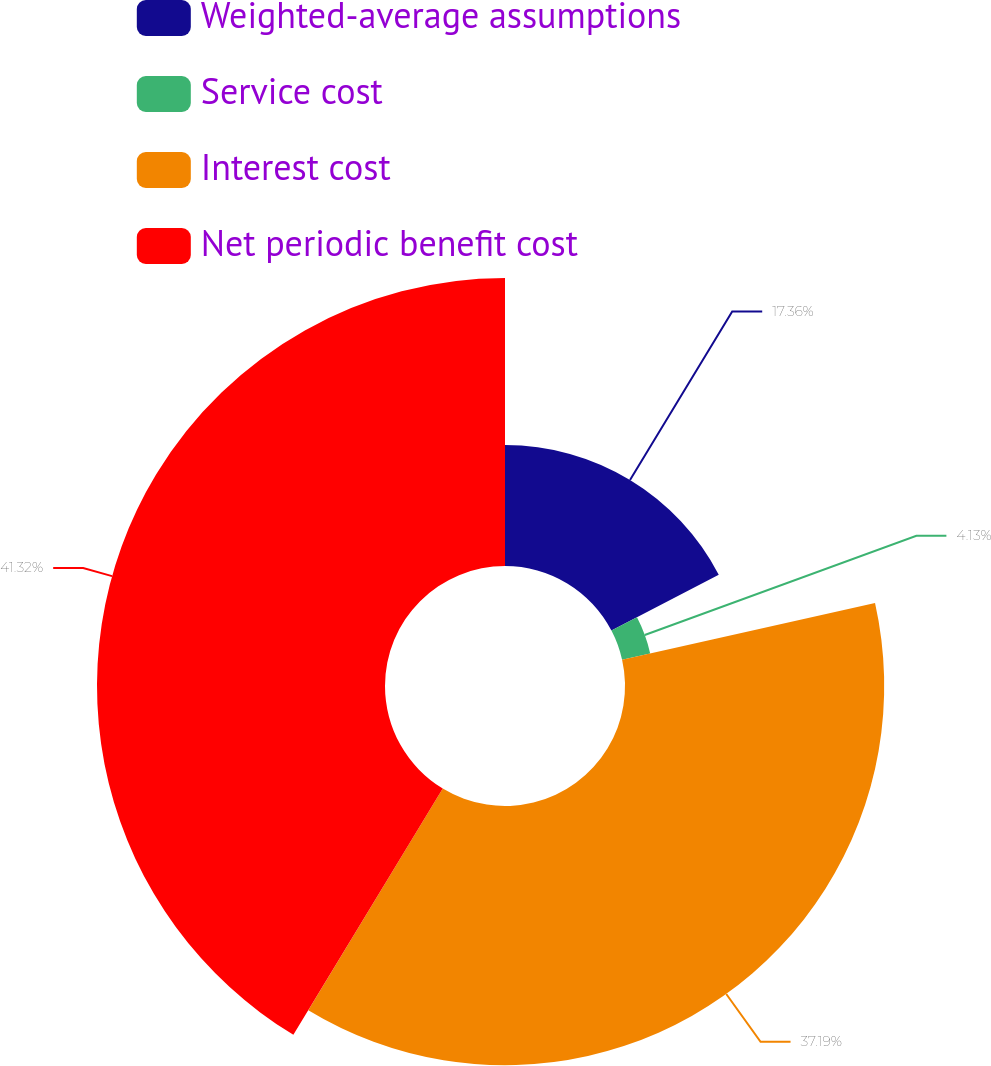<chart> <loc_0><loc_0><loc_500><loc_500><pie_chart><fcel>Weighted-average assumptions<fcel>Service cost<fcel>Interest cost<fcel>Net periodic benefit cost<nl><fcel>17.36%<fcel>4.13%<fcel>37.19%<fcel>41.32%<nl></chart> 